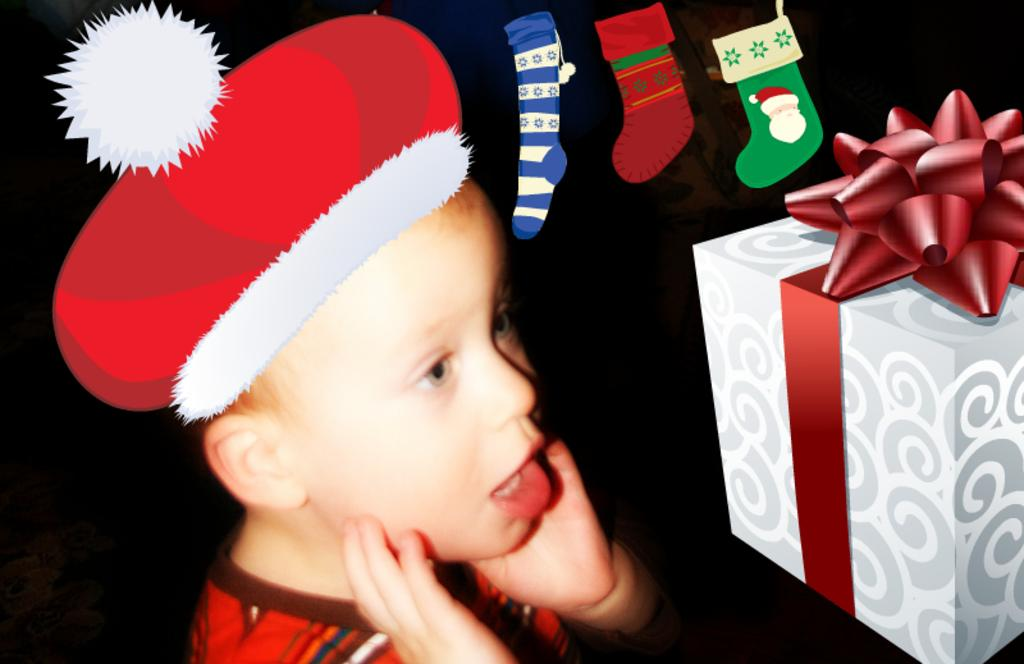Who is present in the image? There is a boy in the image. What objects in the image appear to be animated? There is an animated box, animated socks, and an animated hat in the image. Where is the dock located in the image? There is no dock present in the image. What type of paper is being used by the boy in the image? There is no paper visible in the image. 